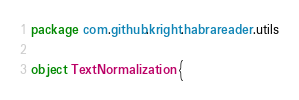<code> <loc_0><loc_0><loc_500><loc_500><_Scala_>package com.github.kright.habrareader.utils

object TextNormalization {
</code> 